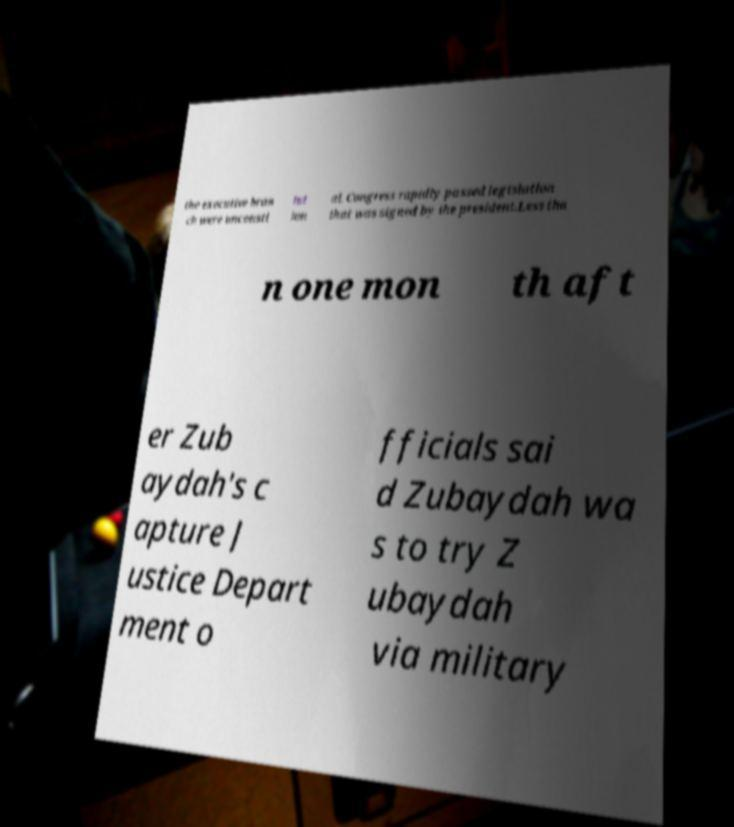What messages or text are displayed in this image? I need them in a readable, typed format. the executive bran ch were unconsti tut ion al. Congress rapidly passed legislation that was signed by the president.Less tha n one mon th aft er Zub aydah's c apture J ustice Depart ment o fficials sai d Zubaydah wa s to try Z ubaydah via military 